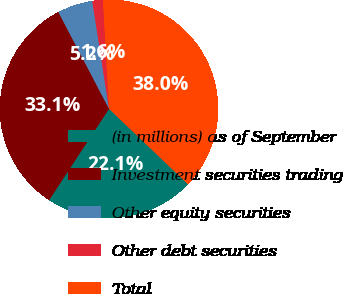<chart> <loc_0><loc_0><loc_500><loc_500><pie_chart><fcel>(in millions) as of September<fcel>Investment securities trading<fcel>Other equity securities<fcel>Other debt securities<fcel>Total<nl><fcel>22.11%<fcel>33.08%<fcel>5.22%<fcel>1.57%<fcel>38.02%<nl></chart> 